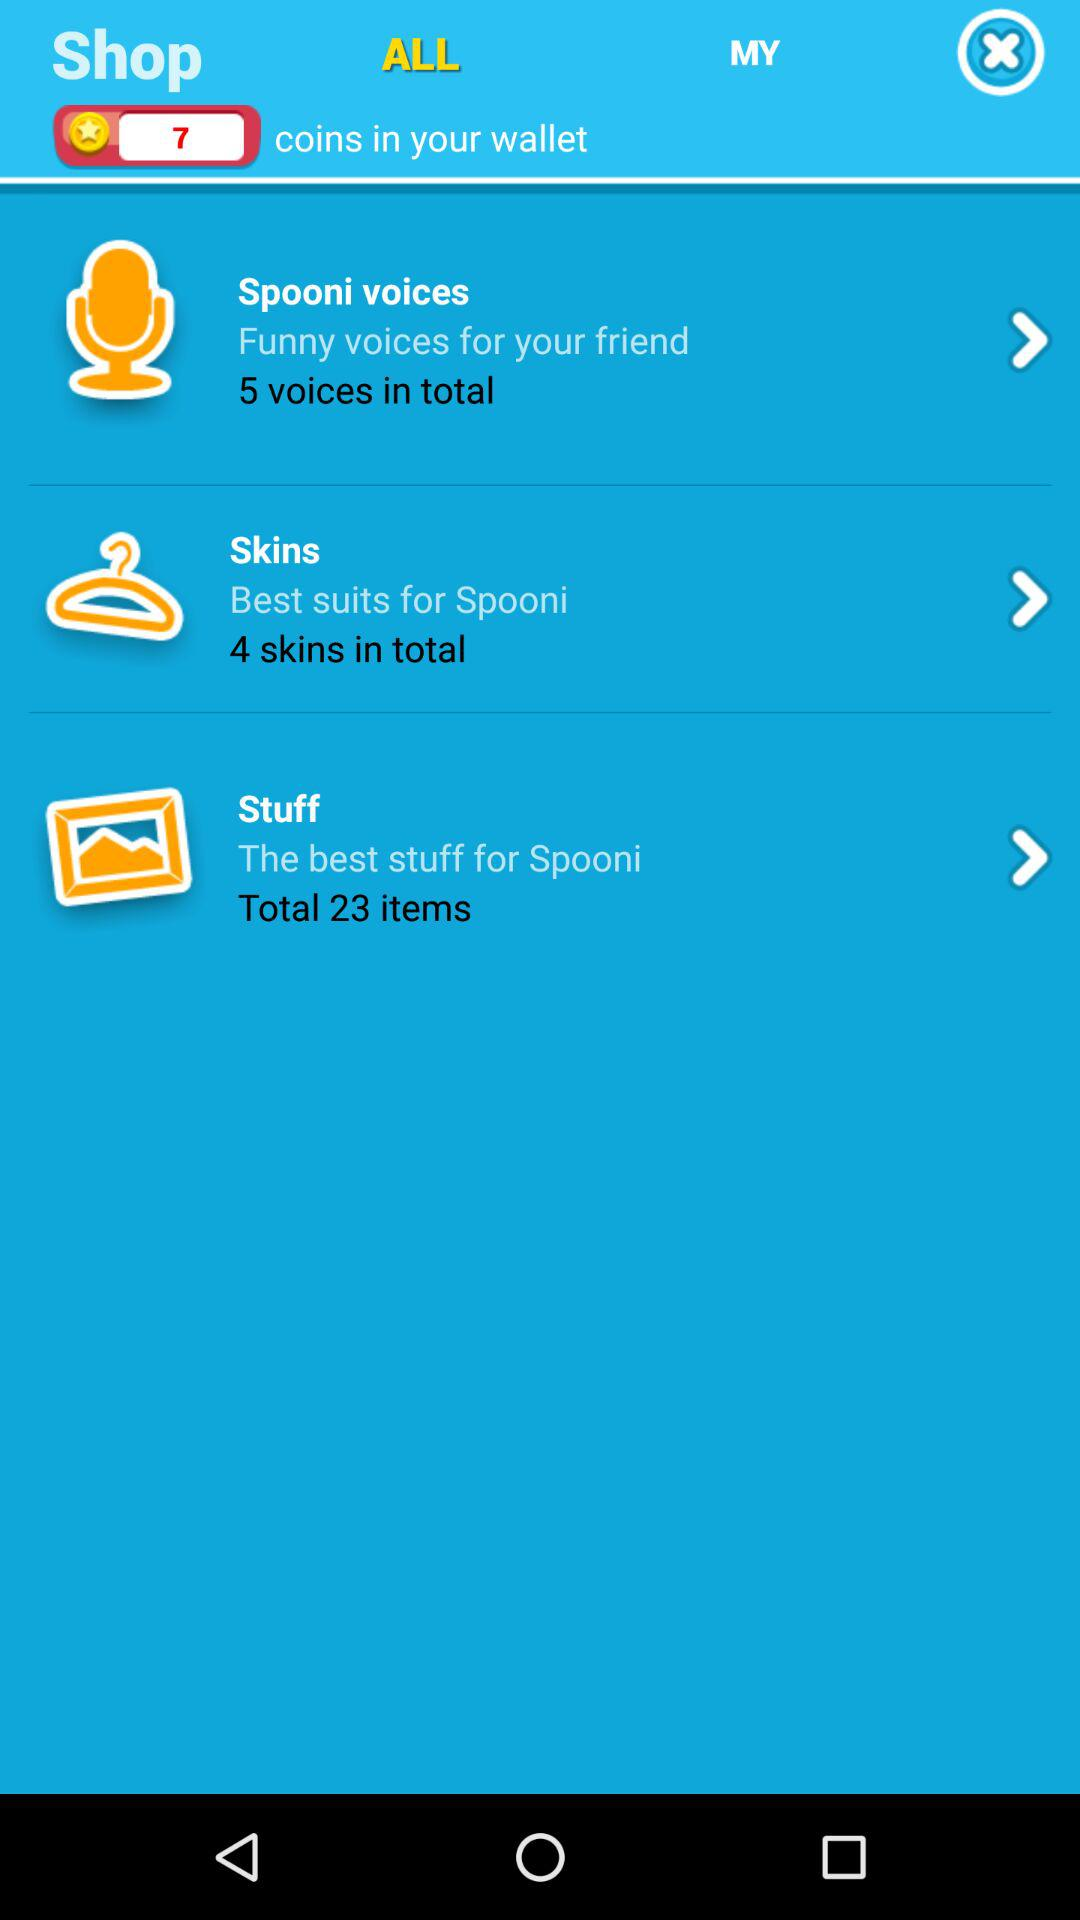How many coins are in the wallet? There are 7 coins in the wallet. 